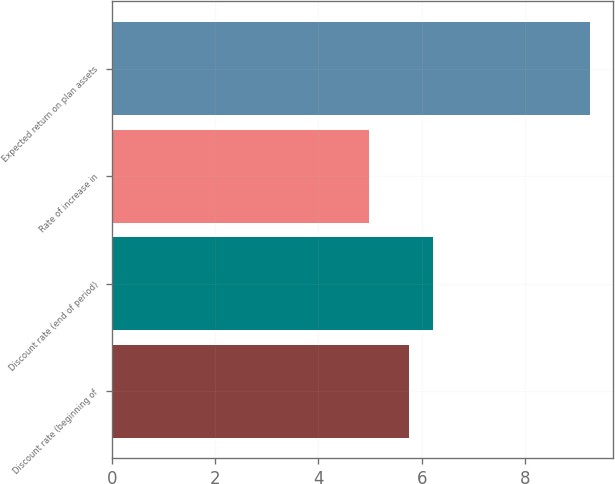Convert chart to OTSL. <chart><loc_0><loc_0><loc_500><loc_500><bar_chart><fcel>Discount rate (beginning of<fcel>Discount rate (end of period)<fcel>Rate of increase in<fcel>Expected return on plan assets<nl><fcel>5.75<fcel>6.22<fcel>4.97<fcel>9.25<nl></chart> 